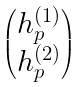<formula> <loc_0><loc_0><loc_500><loc_500>\begin{pmatrix} h ^ { ( 1 ) } _ { p } \\ h ^ { ( 2 ) } _ { p } \end{pmatrix}</formula> 